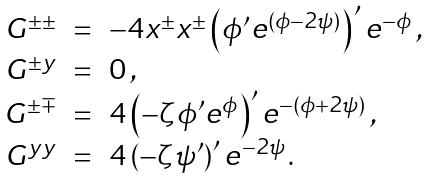Convert formula to latex. <formula><loc_0><loc_0><loc_500><loc_500>\begin{array} { r c l } G ^ { \pm \pm } & = & - 4 x ^ { \pm } x ^ { \pm } \left ( \phi ^ { \prime } e ^ { ( \phi - 2 \psi ) } \right ) ^ { \prime } e ^ { - \phi } \, , \\ G ^ { \pm y } & = & 0 \, , \\ G ^ { \pm \mp } & = & 4 \left ( - \zeta \phi ^ { \prime } e ^ { \phi } \right ) ^ { \prime } e ^ { - ( \phi + 2 \psi ) } \, , \\ G ^ { y y } & = & 4 \left ( - \zeta \psi ^ { \prime } \right ) ^ { \prime } e ^ { - 2 \psi } \, . \end{array}</formula> 